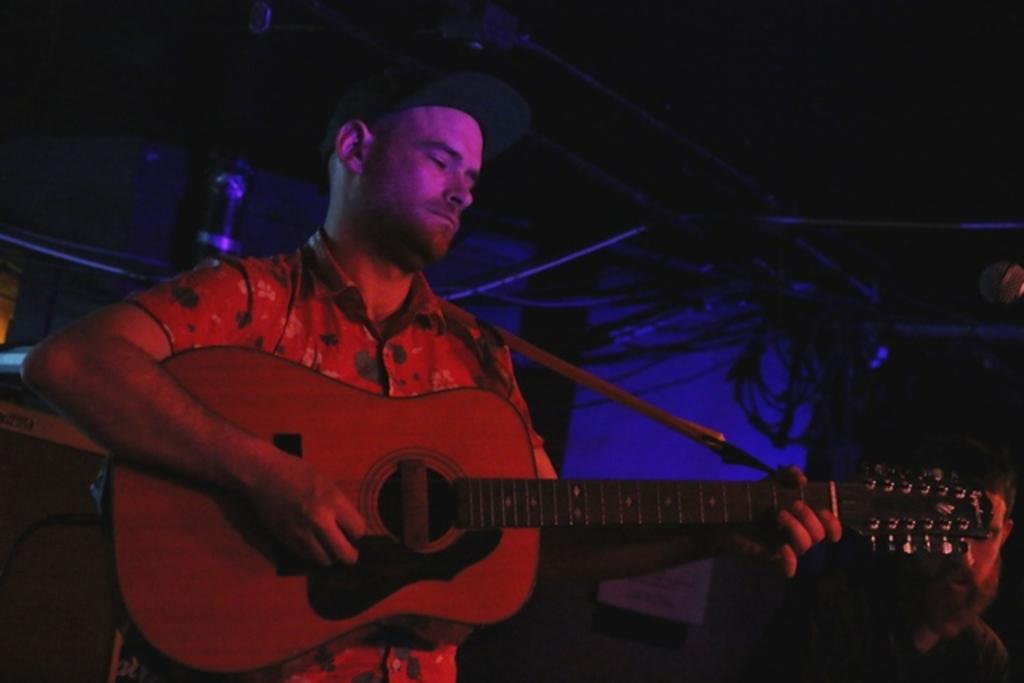Who is the main subject in the image? There is a man in the image. What is the man wearing on his head? The man is wearing a cap. What is the man doing in the image? The man is playing a guitar. How can you describe the background of the image? The background of the image is dark. What type of hammer is the man holding in the image? There is no hammer present in the image; the man is playing a guitar. Can you see any roses in the image? There are no roses visible in the image. 